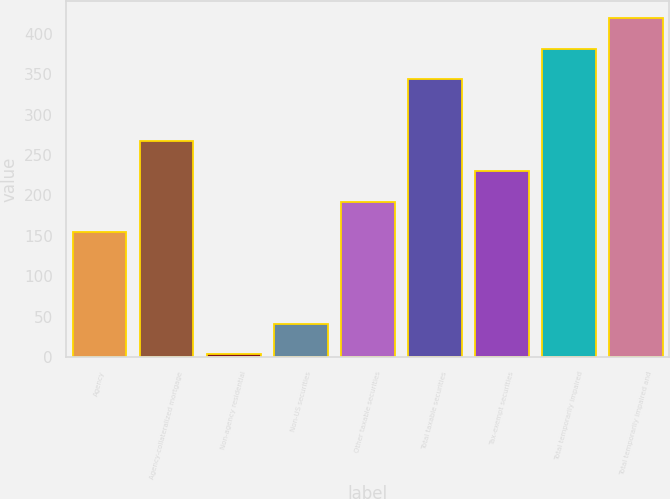<chart> <loc_0><loc_0><loc_500><loc_500><bar_chart><fcel>Agency<fcel>Agency-collateralized mortgage<fcel>Non-agency residential<fcel>Non-US securities<fcel>Other taxable securities<fcel>Total taxable securities<fcel>Tax-exempt securities<fcel>Total temporarily impaired<fcel>Total temporarily impaired and<nl><fcel>154.8<fcel>267.9<fcel>4<fcel>41.7<fcel>192.5<fcel>343.3<fcel>230.2<fcel>381<fcel>418.7<nl></chart> 